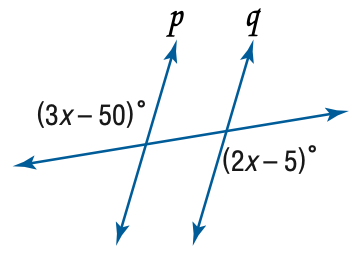Question: Find x so that p \parallel q.
Choices:
A. 11
B. 40
C. 45
D. 55
Answer with the letter. Answer: C 